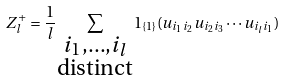Convert formula to latex. <formula><loc_0><loc_0><loc_500><loc_500>Z _ { l } ^ { + } = \frac { 1 } { l } \sum _ { \substack { i _ { 1 } , \dots , i _ { l } \\ \text {distinct} } } 1 _ { \{ 1 \} } ( u _ { i _ { 1 } i _ { 2 } } u _ { i _ { 2 } i _ { 3 } } \cdots u _ { i _ { l } i _ { 1 } } )</formula> 